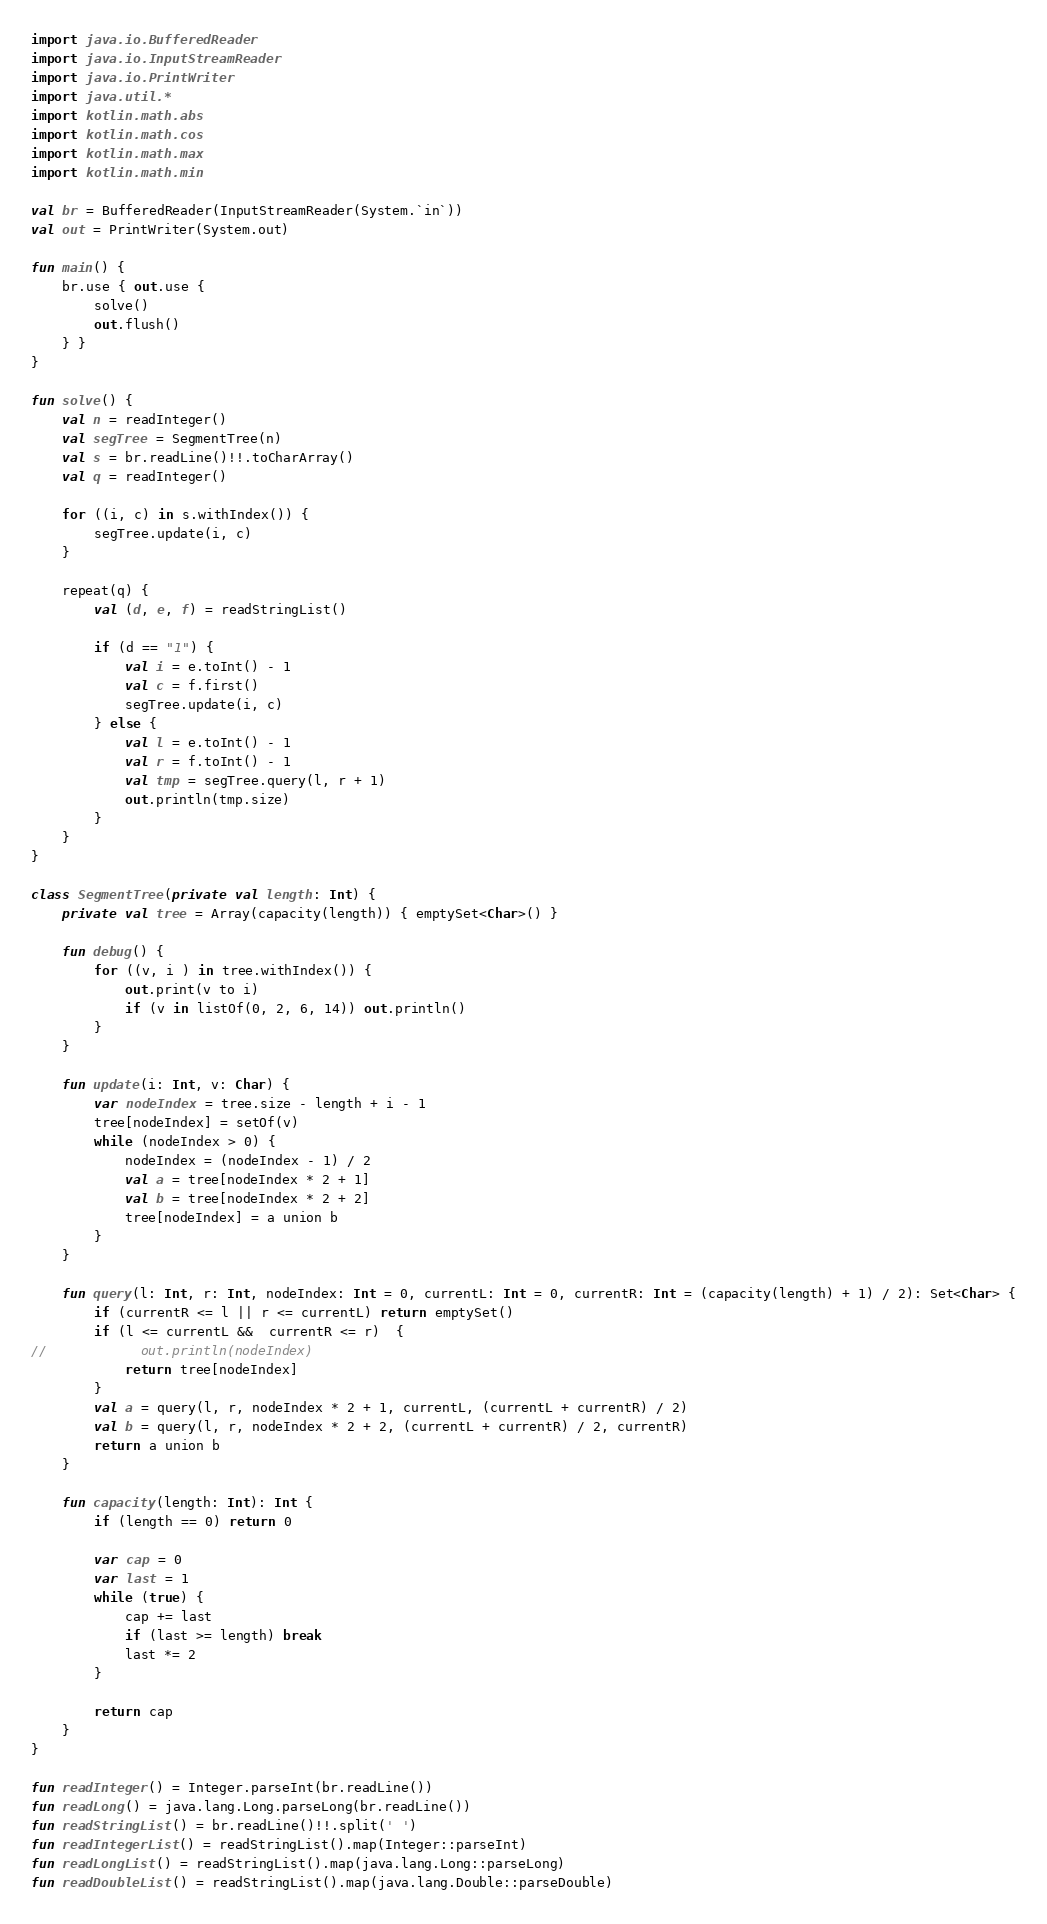<code> <loc_0><loc_0><loc_500><loc_500><_Kotlin_>import java.io.BufferedReader
import java.io.InputStreamReader
import java.io.PrintWriter
import java.util.*
import kotlin.math.abs
import kotlin.math.cos
import kotlin.math.max
import kotlin.math.min

val br = BufferedReader(InputStreamReader(System.`in`))
val out = PrintWriter(System.out)

fun main() {
    br.use { out.use {
        solve()
        out.flush()
    } }
}

fun solve() {
    val n = readInteger()
    val segTree = SegmentTree(n)
    val s = br.readLine()!!.toCharArray()
    val q = readInteger()

    for ((i, c) in s.withIndex()) {
        segTree.update(i, c)
    }

    repeat(q) {
        val (d, e, f) = readStringList()

        if (d == "1") {
            val i = e.toInt() - 1
            val c = f.first()
            segTree.update(i, c)
        } else {
            val l = e.toInt() - 1
            val r = f.toInt() - 1
            val tmp = segTree.query(l, r + 1)
            out.println(tmp.size)
        }
    }
}

class SegmentTree(private val length: Int) {
    private val tree = Array(capacity(length)) { emptySet<Char>() }

    fun debug() {
        for ((v, i ) in tree.withIndex()) {
            out.print(v to i)
            if (v in listOf(0, 2, 6, 14)) out.println()
        }
    }

    fun update(i: Int, v: Char) {
        var nodeIndex = tree.size - length + i - 1
        tree[nodeIndex] = setOf(v)
        while (nodeIndex > 0) {
            nodeIndex = (nodeIndex - 1) / 2
            val a = tree[nodeIndex * 2 + 1]
            val b = tree[nodeIndex * 2 + 2]
            tree[nodeIndex] = a union b
        }
    }

    fun query(l: Int, r: Int, nodeIndex: Int = 0, currentL: Int = 0, currentR: Int = (capacity(length) + 1) / 2): Set<Char> {
        if (currentR <= l || r <= currentL) return emptySet()
        if (l <= currentL &&  currentR <= r)  {
//            out.println(nodeIndex)
            return tree[nodeIndex]
        }
        val a = query(l, r, nodeIndex * 2 + 1, currentL, (currentL + currentR) / 2)
        val b = query(l, r, nodeIndex * 2 + 2, (currentL + currentR) / 2, currentR)
        return a union b
    }

    fun capacity(length: Int): Int {
        if (length == 0) return 0

        var cap = 0
        var last = 1
        while (true) {
            cap += last
            if (last >= length) break
            last *= 2
        }

        return cap
    }
}

fun readInteger() = Integer.parseInt(br.readLine())
fun readLong() = java.lang.Long.parseLong(br.readLine())
fun readStringList() = br.readLine()!!.split(' ')
fun readIntegerList() = readStringList().map(Integer::parseInt)
fun readLongList() = readStringList().map(java.lang.Long::parseLong)
fun readDoubleList() = readStringList().map(java.lang.Double::parseDouble)
</code> 